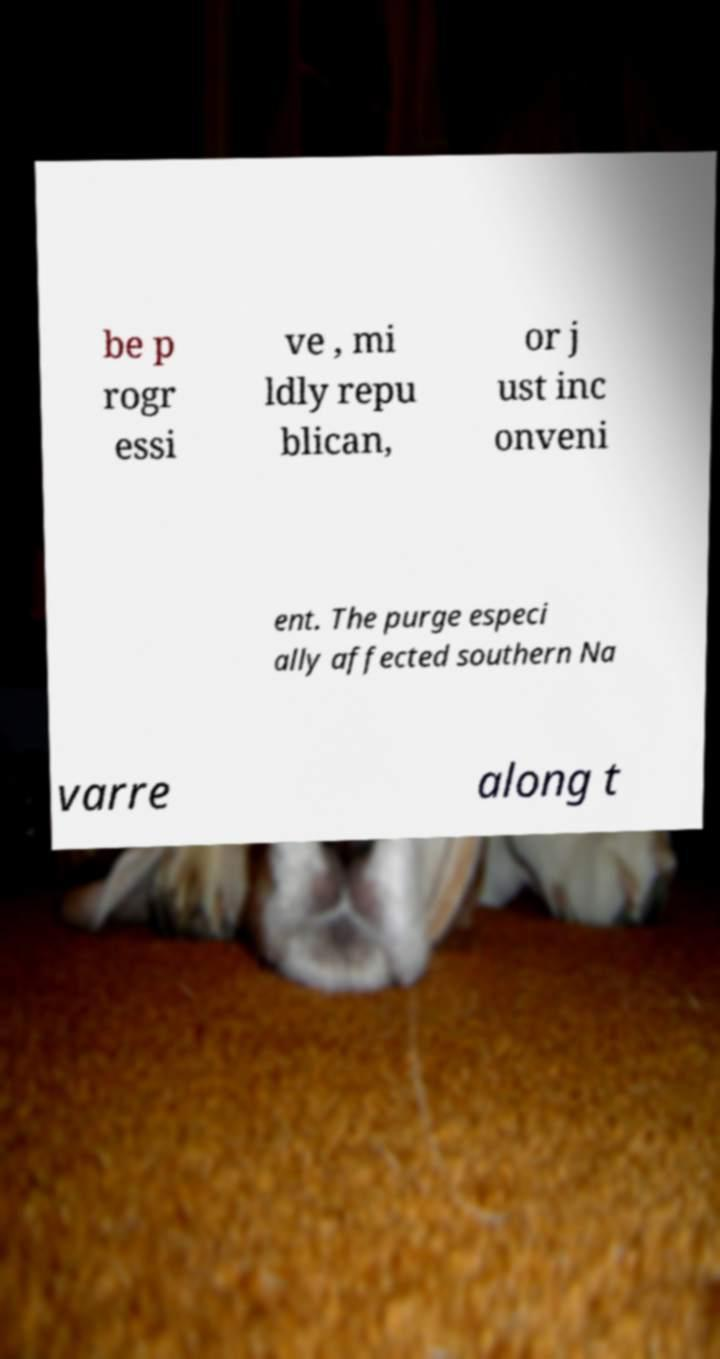Please read and relay the text visible in this image. What does it say? be p rogr essi ve , mi ldly repu blican, or j ust inc onveni ent. The purge especi ally affected southern Na varre along t 